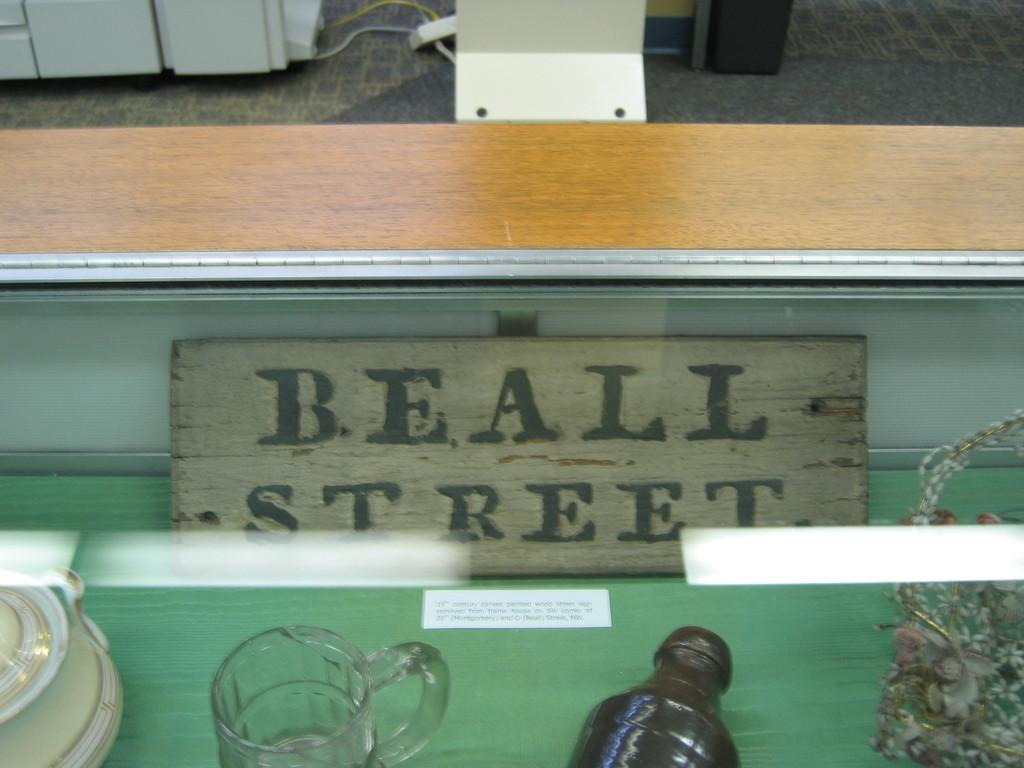<image>
Provide a brief description of the given image. A wood sign has Beall Street on it in black lettering. 